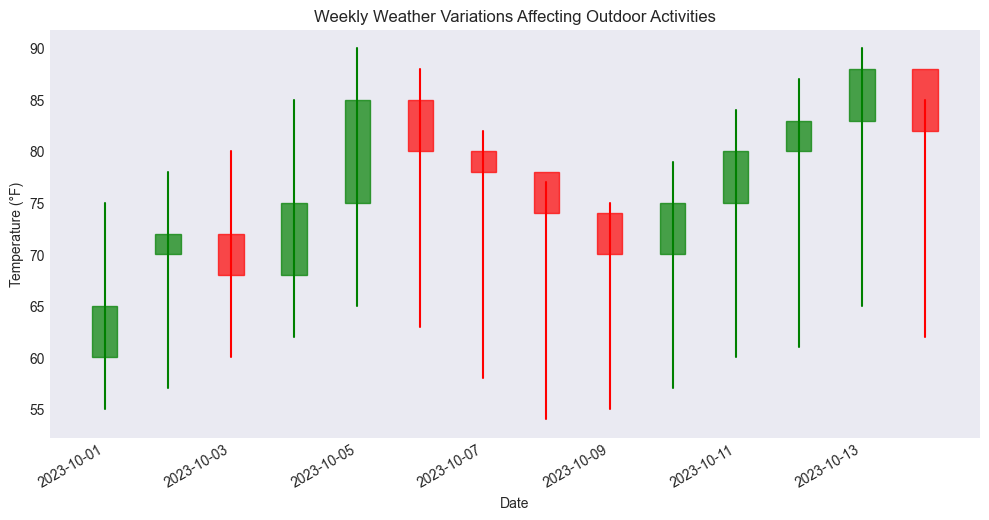What was the highest temperature recorded during this period? Look for the highest value among the High temperatures in the candlestick chart. The highest temperature recorded was 90°F on both October 5 and October 13.
Answer: 90°F Which day had the largest temperature variation? Determine the day with the biggest difference between the High and Low temperatures by visually comparing the length of the candlestick lines. The biggest variation appears on October 5 with a range from 65°F to 90°F (a difference of 25°F).
Answer: October 5 On which day(s) did the temperature close lower than it opened? Identify where the red candles are because they signify days when the closing temperature was lower than the opening temperature. The red candles are seen on October 3, October 6, October 7, October 8, October 9, October 14.
Answer: October 3, October 6, October 7, October 8, October 9, October 14 What is the average high temperature over the period? Sum the high temperatures for each day and divide by the number of days. The high temperatures sum to 1205, and there are 14 days. Therefore, the average high temperature is 1205/14.
Answer: 86.07°F How many days had a closing temperature of 80°F or higher? Count the number of days where the closing temperature is 80°F or above by looking at the top part of the green rectangles and the bottom part of the red rectangles. The days are October 5, October 6, October 11, October 13.
Answer: 4 Which day had the lowest closing temperature, and what was it? Find the lowest value in the Close temperatures on the chart and identify the corresponding day. The lowest closing temperature was 65°F on October 1.
Answer: October 1, 65°F On which day did the temperature increase the most from open to close? Calculate the difference between open and close temperatures for each day and identify the largest positive difference. On October 5, the open was 75°F and the close was 85°F (a 10°F increase).
Answer: October 5 Was there any day where the open and close temperatures were the same? Check for days where the height of the candlestick body (the rectangle) is zero, meaning the temperatures were identical. There was no day with identical open and close temperatures.
Answer: No 